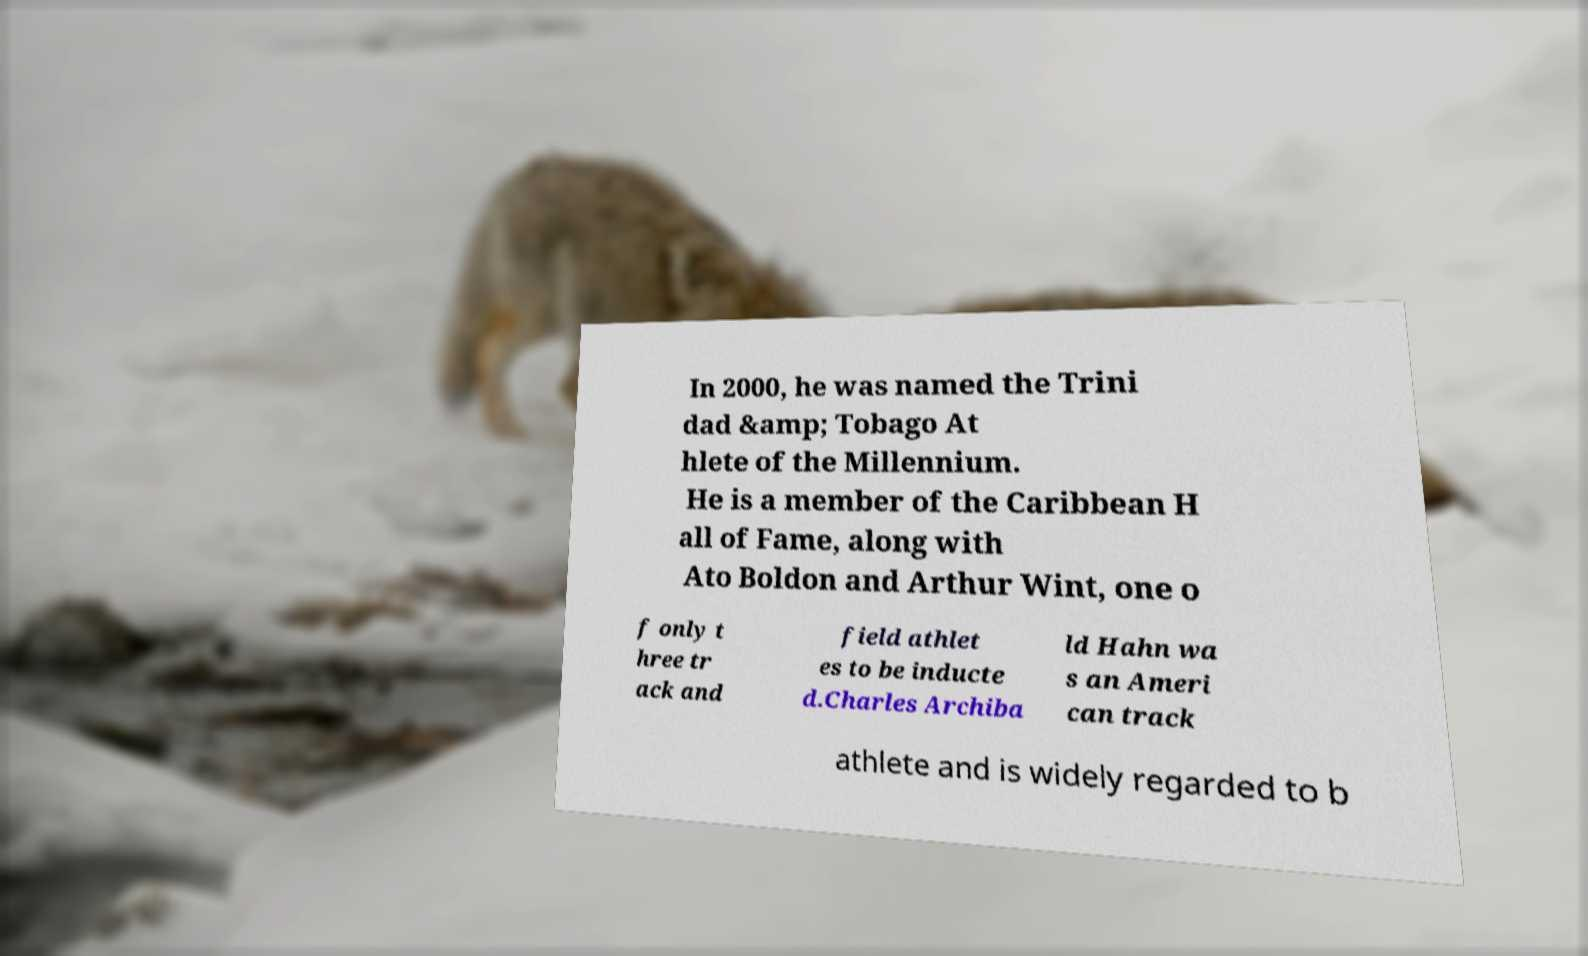Please read and relay the text visible in this image. What does it say? In 2000, he was named the Trini dad &amp; Tobago At hlete of the Millennium. He is a member of the Caribbean H all of Fame, along with Ato Boldon and Arthur Wint, one o f only t hree tr ack and field athlet es to be inducte d.Charles Archiba ld Hahn wa s an Ameri can track athlete and is widely regarded to b 